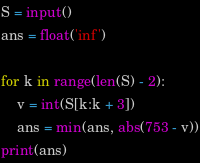Convert code to text. <code><loc_0><loc_0><loc_500><loc_500><_Python_>S = input()
ans = float('inf')

for k in range(len(S) - 2):
    v = int(S[k:k + 3])
    ans = min(ans, abs(753 - v))
print(ans)</code> 